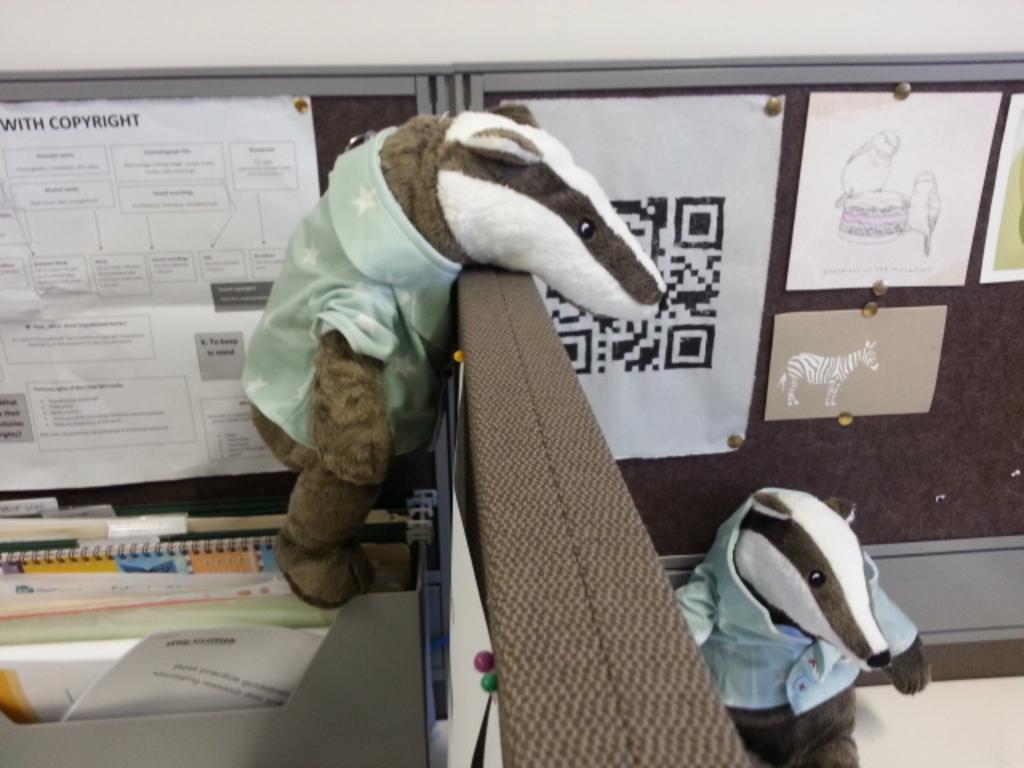Can you describe this image briefly? In this image I can see there are two soft toys and there is a notice board attached in the backdrop and there are few papers attached to it. There are few files arranged in left side. 